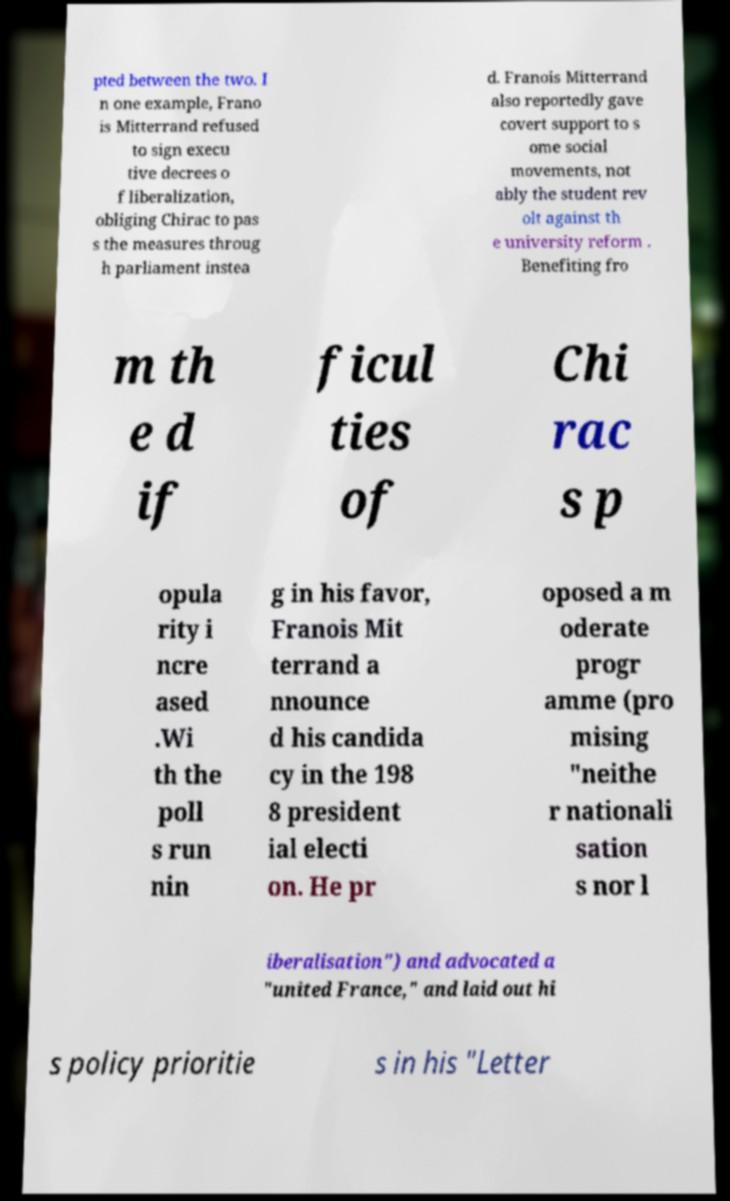There's text embedded in this image that I need extracted. Can you transcribe it verbatim? pted between the two. I n one example, Frano is Mitterrand refused to sign execu tive decrees o f liberalization, obliging Chirac to pas s the measures throug h parliament instea d. Franois Mitterrand also reportedly gave covert support to s ome social movements, not ably the student rev olt against th e university reform . Benefiting fro m th e d if ficul ties of Chi rac s p opula rity i ncre ased .Wi th the poll s run nin g in his favor, Franois Mit terrand a nnounce d his candida cy in the 198 8 president ial electi on. He pr oposed a m oderate progr amme (pro mising "neithe r nationali sation s nor l iberalisation") and advocated a "united France," and laid out hi s policy prioritie s in his "Letter 